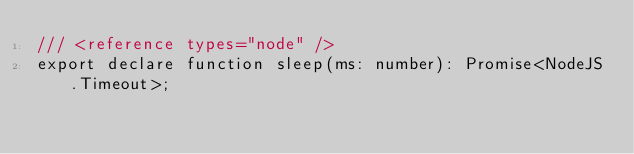<code> <loc_0><loc_0><loc_500><loc_500><_TypeScript_>/// <reference types="node" />
export declare function sleep(ms: number): Promise<NodeJS.Timeout>;
</code> 